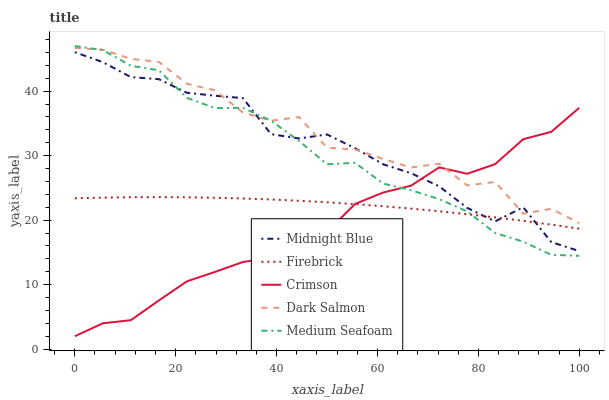Does Crimson have the minimum area under the curve?
Answer yes or no. Yes. Does Dark Salmon have the maximum area under the curve?
Answer yes or no. Yes. Does Firebrick have the minimum area under the curve?
Answer yes or no. No. Does Firebrick have the maximum area under the curve?
Answer yes or no. No. Is Firebrick the smoothest?
Answer yes or no. Yes. Is Dark Salmon the roughest?
Answer yes or no. Yes. Is Medium Seafoam the smoothest?
Answer yes or no. No. Is Medium Seafoam the roughest?
Answer yes or no. No. Does Crimson have the lowest value?
Answer yes or no. Yes. Does Firebrick have the lowest value?
Answer yes or no. No. Does Medium Seafoam have the highest value?
Answer yes or no. Yes. Does Firebrick have the highest value?
Answer yes or no. No. Is Firebrick less than Dark Salmon?
Answer yes or no. Yes. Is Dark Salmon greater than Firebrick?
Answer yes or no. Yes. Does Midnight Blue intersect Crimson?
Answer yes or no. Yes. Is Midnight Blue less than Crimson?
Answer yes or no. No. Is Midnight Blue greater than Crimson?
Answer yes or no. No. Does Firebrick intersect Dark Salmon?
Answer yes or no. No. 